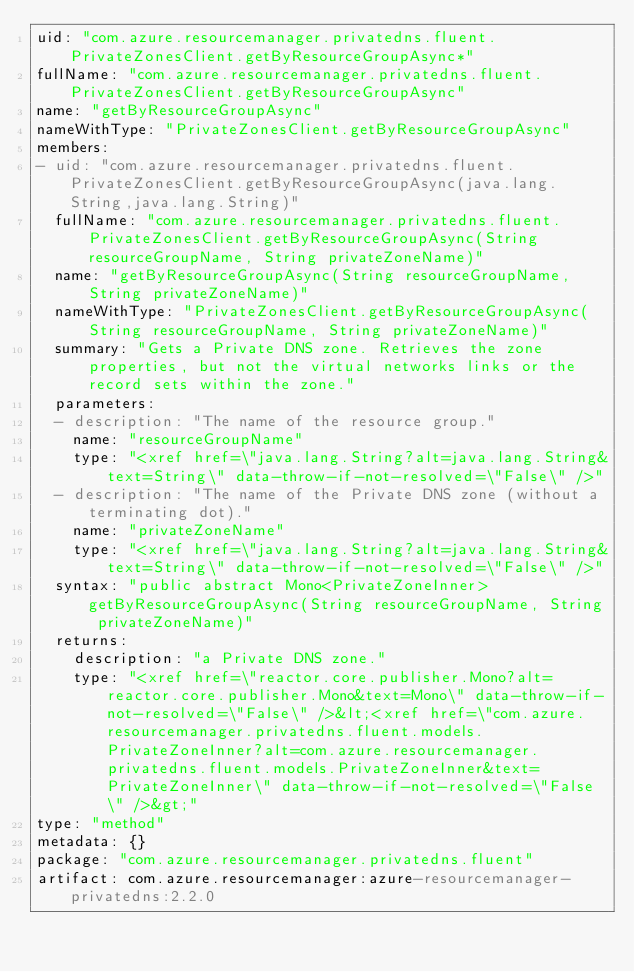Convert code to text. <code><loc_0><loc_0><loc_500><loc_500><_YAML_>uid: "com.azure.resourcemanager.privatedns.fluent.PrivateZonesClient.getByResourceGroupAsync*"
fullName: "com.azure.resourcemanager.privatedns.fluent.PrivateZonesClient.getByResourceGroupAsync"
name: "getByResourceGroupAsync"
nameWithType: "PrivateZonesClient.getByResourceGroupAsync"
members:
- uid: "com.azure.resourcemanager.privatedns.fluent.PrivateZonesClient.getByResourceGroupAsync(java.lang.String,java.lang.String)"
  fullName: "com.azure.resourcemanager.privatedns.fluent.PrivateZonesClient.getByResourceGroupAsync(String resourceGroupName, String privateZoneName)"
  name: "getByResourceGroupAsync(String resourceGroupName, String privateZoneName)"
  nameWithType: "PrivateZonesClient.getByResourceGroupAsync(String resourceGroupName, String privateZoneName)"
  summary: "Gets a Private DNS zone. Retrieves the zone properties, but not the virtual networks links or the record sets within the zone."
  parameters:
  - description: "The name of the resource group."
    name: "resourceGroupName"
    type: "<xref href=\"java.lang.String?alt=java.lang.String&text=String\" data-throw-if-not-resolved=\"False\" />"
  - description: "The name of the Private DNS zone (without a terminating dot)."
    name: "privateZoneName"
    type: "<xref href=\"java.lang.String?alt=java.lang.String&text=String\" data-throw-if-not-resolved=\"False\" />"
  syntax: "public abstract Mono<PrivateZoneInner> getByResourceGroupAsync(String resourceGroupName, String privateZoneName)"
  returns:
    description: "a Private DNS zone."
    type: "<xref href=\"reactor.core.publisher.Mono?alt=reactor.core.publisher.Mono&text=Mono\" data-throw-if-not-resolved=\"False\" />&lt;<xref href=\"com.azure.resourcemanager.privatedns.fluent.models.PrivateZoneInner?alt=com.azure.resourcemanager.privatedns.fluent.models.PrivateZoneInner&text=PrivateZoneInner\" data-throw-if-not-resolved=\"False\" />&gt;"
type: "method"
metadata: {}
package: "com.azure.resourcemanager.privatedns.fluent"
artifact: com.azure.resourcemanager:azure-resourcemanager-privatedns:2.2.0
</code> 